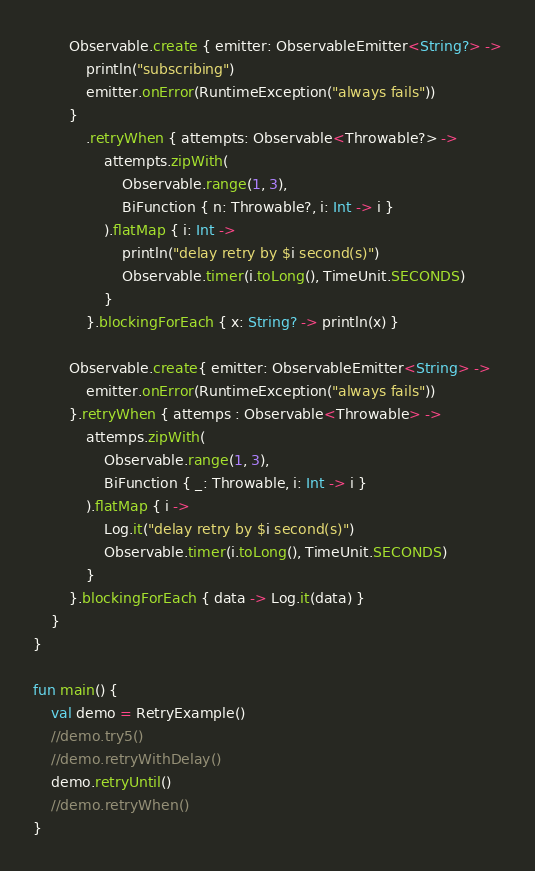<code> <loc_0><loc_0><loc_500><loc_500><_Kotlin_>        Observable.create { emitter: ObservableEmitter<String?> ->
            println("subscribing")
            emitter.onError(RuntimeException("always fails"))
        }
            .retryWhen { attempts: Observable<Throwable?> ->
                attempts.zipWith(
                    Observable.range(1, 3),
                    BiFunction { n: Throwable?, i: Int -> i }
                ).flatMap { i: Int ->
                    println("delay retry by $i second(s)")
                    Observable.timer(i.toLong(), TimeUnit.SECONDS)
                }
            }.blockingForEach { x: String? -> println(x) }

        Observable.create{ emitter: ObservableEmitter<String> ->
            emitter.onError(RuntimeException("always fails"))
        }.retryWhen { attemps : Observable<Throwable> ->
            attemps.zipWith(
                Observable.range(1, 3),
                BiFunction { _: Throwable, i: Int -> i }
            ).flatMap { i ->
                Log.it("delay retry by $i second(s)")
                Observable.timer(i.toLong(), TimeUnit.SECONDS)
            }
        }.blockingForEach { data -> Log.it(data) }
    }
}

fun main() {
    val demo = RetryExample()
    //demo.try5()
    //demo.retryWithDelay()
    demo.retryUntil()
    //demo.retryWhen()
}</code> 